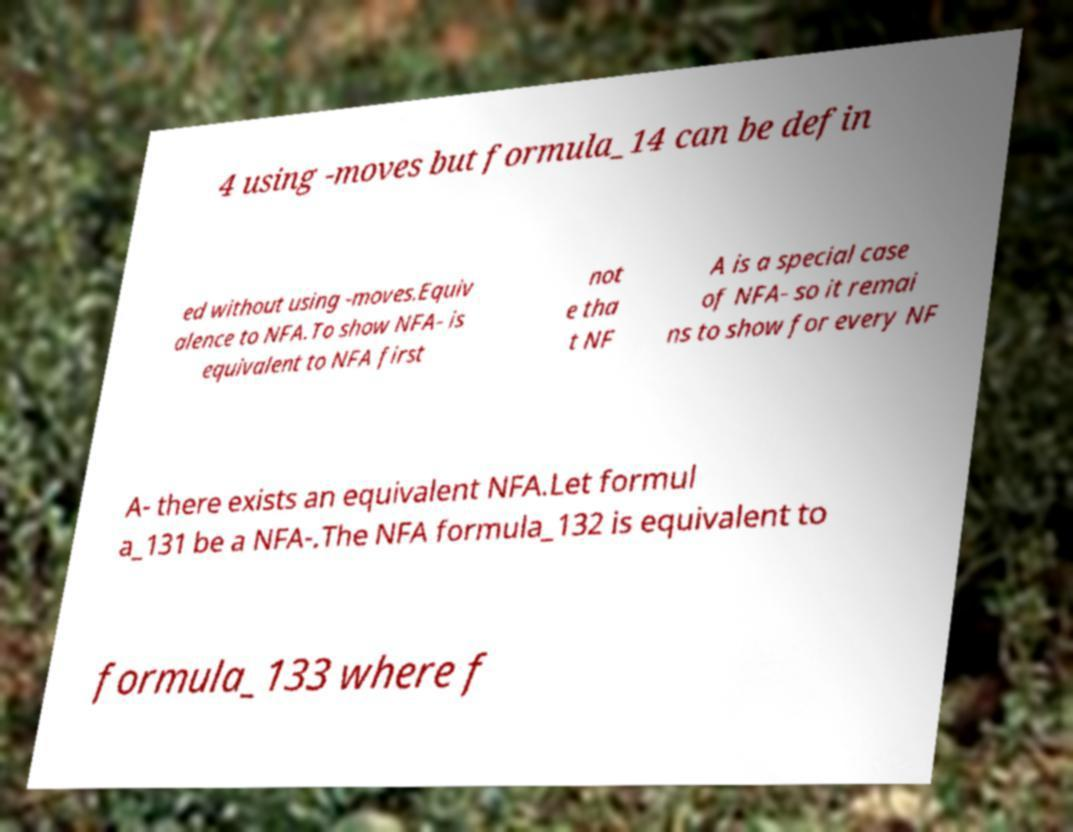Please identify and transcribe the text found in this image. 4 using -moves but formula_14 can be defin ed without using -moves.Equiv alence to NFA.To show NFA- is equivalent to NFA first not e tha t NF A is a special case of NFA- so it remai ns to show for every NF A- there exists an equivalent NFA.Let formul a_131 be a NFA-.The NFA formula_132 is equivalent to formula_133 where f 